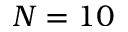Convert formula to latex. <formula><loc_0><loc_0><loc_500><loc_500>N = 1 0</formula> 